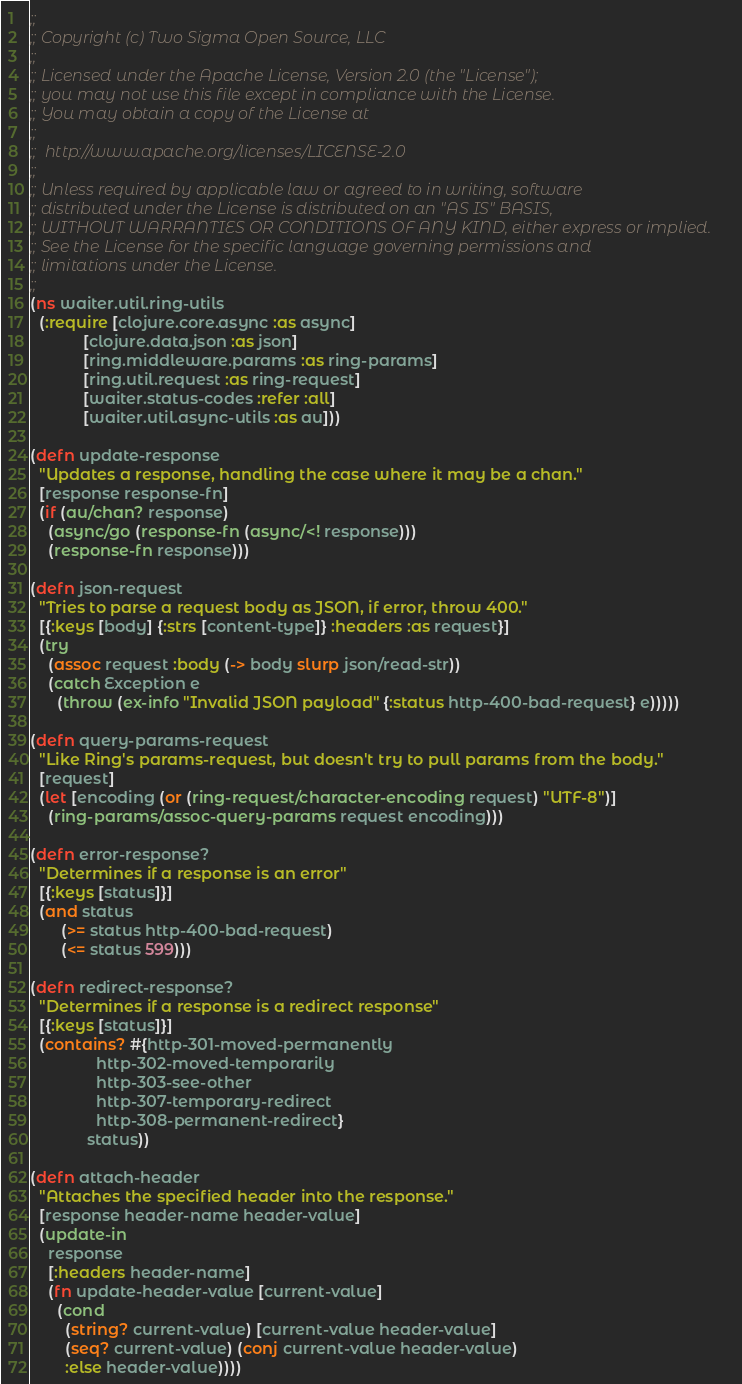<code> <loc_0><loc_0><loc_500><loc_500><_Clojure_>;;
;; Copyright (c) Two Sigma Open Source, LLC
;;
;; Licensed under the Apache License, Version 2.0 (the "License");
;; you may not use this file except in compliance with the License.
;; You may obtain a copy of the License at
;;
;;  http://www.apache.org/licenses/LICENSE-2.0
;;
;; Unless required by applicable law or agreed to in writing, software
;; distributed under the License is distributed on an "AS IS" BASIS,
;; WITHOUT WARRANTIES OR CONDITIONS OF ANY KIND, either express or implied.
;; See the License for the specific language governing permissions and
;; limitations under the License.
;;
(ns waiter.util.ring-utils
  (:require [clojure.core.async :as async]
            [clojure.data.json :as json]
            [ring.middleware.params :as ring-params]
            [ring.util.request :as ring-request]
            [waiter.status-codes :refer :all]
            [waiter.util.async-utils :as au]))

(defn update-response
  "Updates a response, handling the case where it may be a chan."
  [response response-fn]
  (if (au/chan? response)
    (async/go (response-fn (async/<! response)))
    (response-fn response)))

(defn json-request
  "Tries to parse a request body as JSON, if error, throw 400."
  [{:keys [body] {:strs [content-type]} :headers :as request}]
  (try
    (assoc request :body (-> body slurp json/read-str))
    (catch Exception e
      (throw (ex-info "Invalid JSON payload" {:status http-400-bad-request} e)))))

(defn query-params-request
  "Like Ring's params-request, but doesn't try to pull params from the body."
  [request]
  (let [encoding (or (ring-request/character-encoding request) "UTF-8")]
    (ring-params/assoc-query-params request encoding)))

(defn error-response?
  "Determines if a response is an error"
  [{:keys [status]}]
  (and status
       (>= status http-400-bad-request)
       (<= status 599)))

(defn redirect-response?
  "Determines if a response is a redirect response"
  [{:keys [status]}]
  (contains? #{http-301-moved-permanently
               http-302-moved-temporarily
               http-303-see-other
               http-307-temporary-redirect
               http-308-permanent-redirect}
             status))

(defn attach-header
  "Attaches the specified header into the response."
  [response header-name header-value]
  (update-in
    response
    [:headers header-name]
    (fn update-header-value [current-value]
      (cond
        (string? current-value) [current-value header-value]
        (seq? current-value) (conj current-value header-value)
        :else header-value))))
</code> 